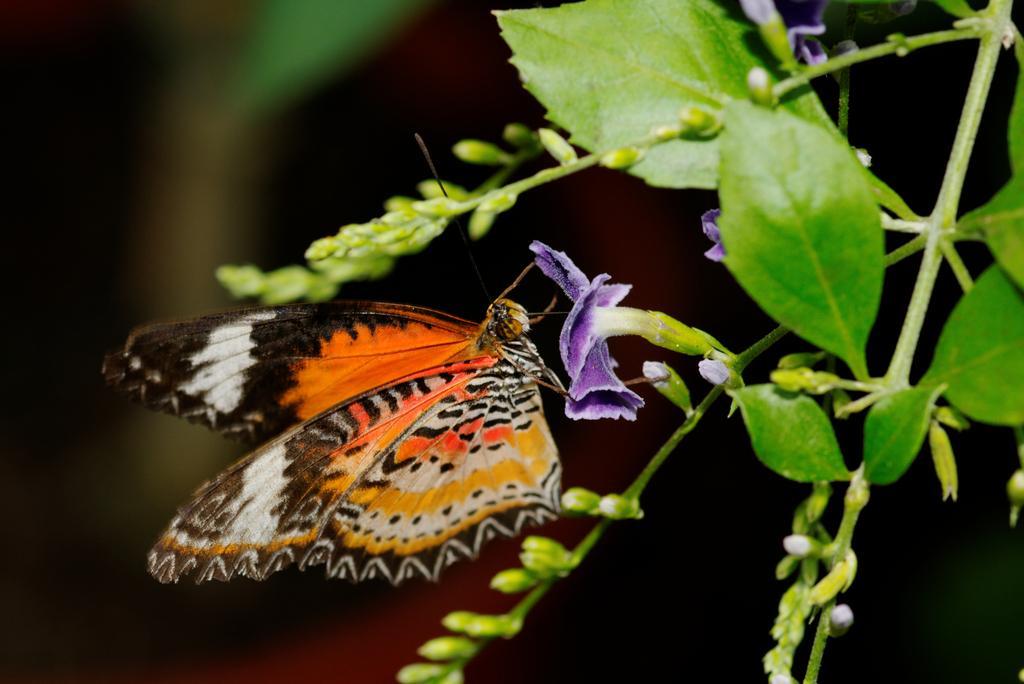In one or two sentences, can you explain what this image depicts? In this image we can see a plant and flowers and there is a butterfly on the flower. In the background, the image is dark. 